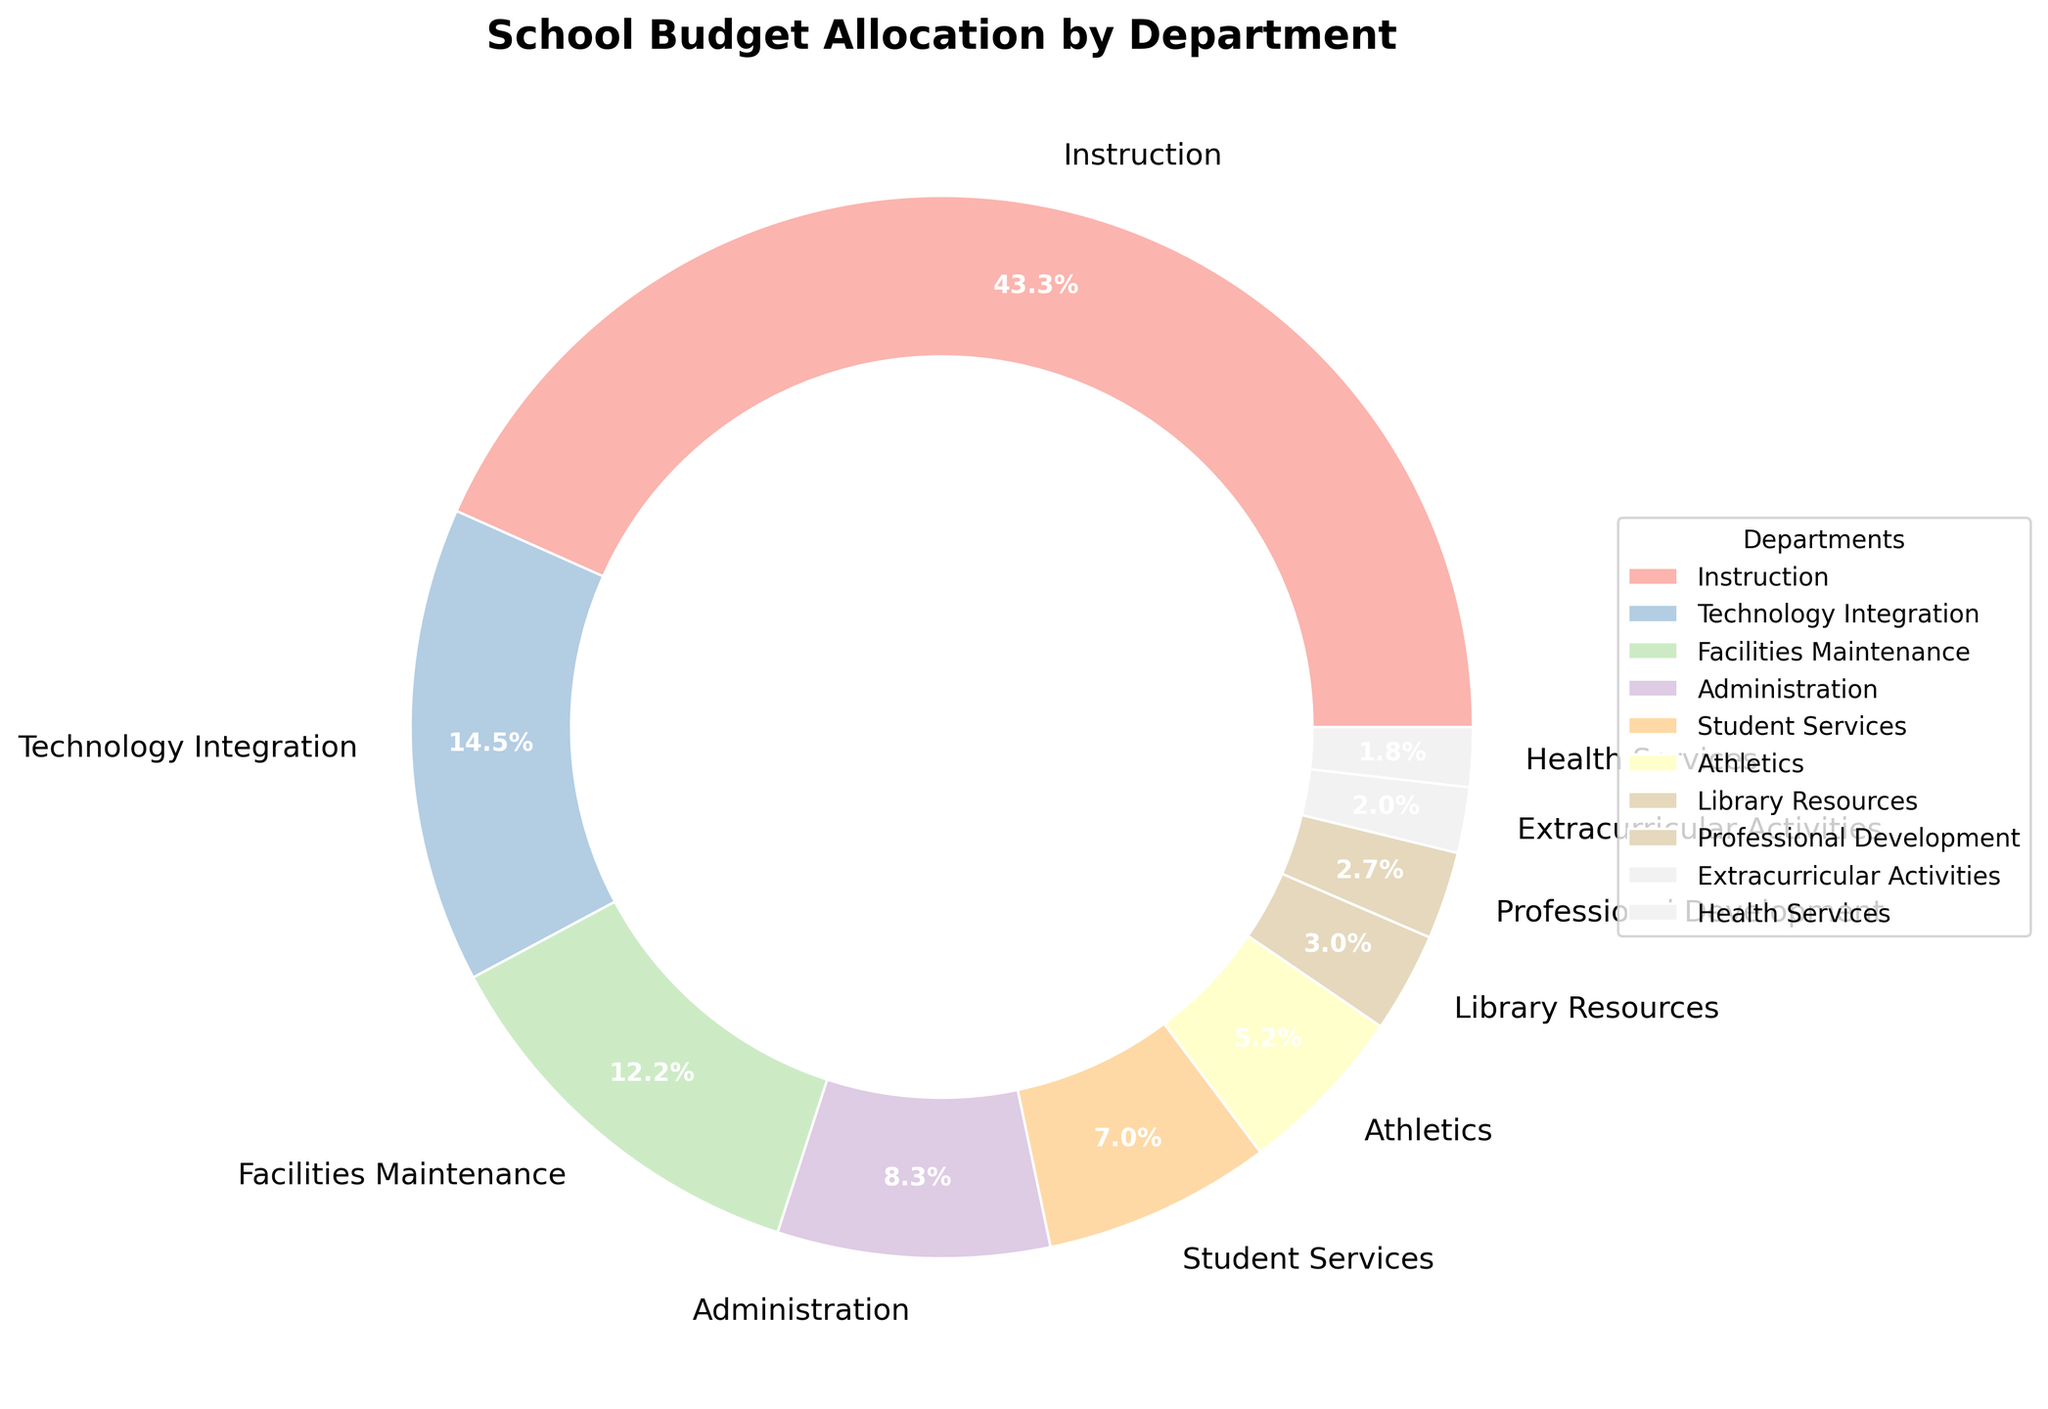What is the largest percentage allocation and which department does it belong to? The pie chart shows that the 'Instruction' department has the largest slice with a percentage of 45.5%.
Answer: Instruction, 45.5% Which department has the smallest budget allocation? The smallest slice in the pie chart belongs to the 'Health Services' department with a percentage of 1.9%.
Answer: Health Services, 1.9% How much more budget allocation does Instruction have compared to Technology Integration? The pie chart shows Instruction at 45.5% and Technology Integration at 15.2%. The difference is 45.5% - 15.2% = 30.3%.
Answer: 30.3% What are the total budget allocations for Athletics, Library Resources, and Professional Development combined? Summing the percentages for Athletics (5.5%), Library Resources (3.2%), and Professional Development (2.8%): 5.5% + 3.2% + 2.8% = 11.5%.
Answer: 11.5% Which departments have a budget allocation greater than 10%? The pie chart shows both 'Instruction' (45.5%) and 'Technology Integration' (15.2%) have greater than 10% allocations.
Answer: Instruction and Technology Integration How much budget allocation does Student Services have compared to Facilities Maintenance? Facilities Maintenance has 12.8% and Student Services has 7.3%. The difference is 12.8% - 7.3% = 5.5%.
Answer: 5.5% Arrange the departments in descending order of their budget allocations. The pie chart shows the following order: Instruction (45.5%), Technology Integration (15.2%), Facilities Maintenance (12.8%), Administration (8.7%), Student Services (7.3%), Athletics (5.5%), Library Resources (3.2%), Professional Development (2.8%), Extracurricular Activities (2.1%), Health Services (1.9%).
Answer: Instruction > Technology Integration > Facilities Maintenance > Administration > Student Services > Athletics > Library Resources > Professional Development > Extracurricular Activities > Health Services What is the combined allocation percentage for Administration and Student Services? Summing the percentages for Administration (8.7%) and Student Services (7.3%): 8.7% + 7.3% = 16%.
Answer: 16% If the budget allocation for Extracurricular Activities were doubled, what would be its new percentage? The current allocation for Extracurricular Activities is 2.1%. Doubling this: 2.1% * 2 = 4.2%.
Answer: 4.2% How does the budget allocation for Technology Integration compare to the total allocation for Athletics, Library Resources, and Professional Development? Technology Integration is 15.2%, while the combined allocation for Athletics (5.5%), Library Resources (3.2%), and Professional Development (2.8%) is 11.5%. So, Technology Integration (15.2%) is greater than the combined total (11.5%).
Answer: Greater 